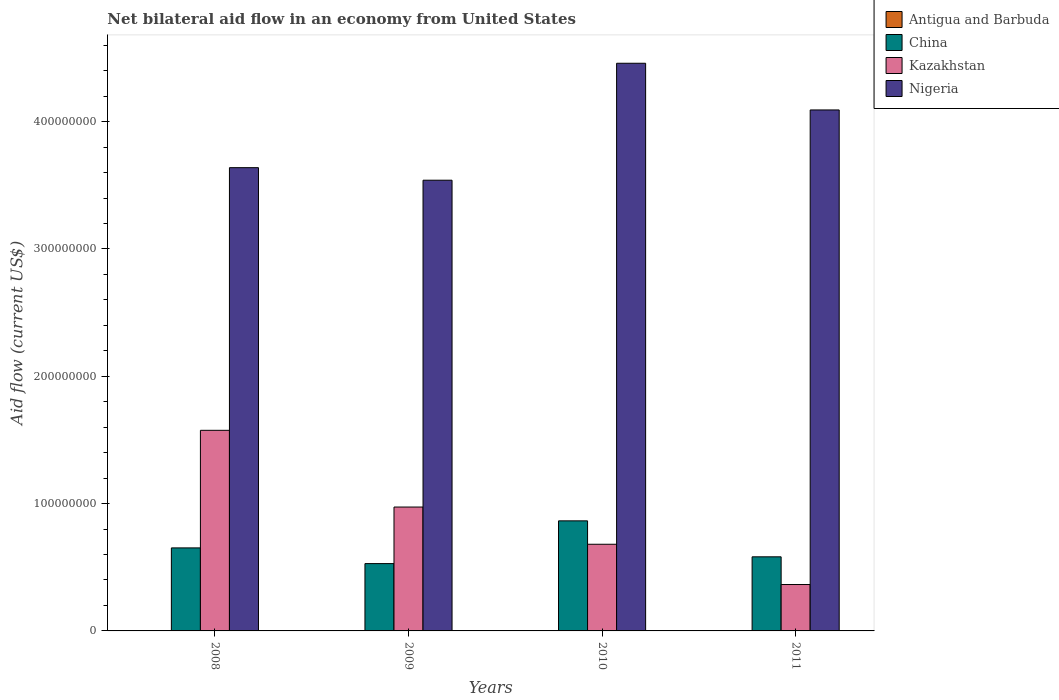How many different coloured bars are there?
Make the answer very short. 4. How many bars are there on the 2nd tick from the left?
Provide a short and direct response. 3. How many bars are there on the 1st tick from the right?
Give a very brief answer. 4. What is the net bilateral aid flow in Kazakhstan in 2008?
Offer a terse response. 1.58e+08. Across all years, what is the minimum net bilateral aid flow in Nigeria?
Keep it short and to the point. 3.54e+08. In which year was the net bilateral aid flow in China maximum?
Make the answer very short. 2010. What is the total net bilateral aid flow in China in the graph?
Your answer should be compact. 2.63e+08. What is the difference between the net bilateral aid flow in Kazakhstan in 2009 and that in 2010?
Make the answer very short. 2.92e+07. What is the difference between the net bilateral aid flow in Kazakhstan in 2008 and the net bilateral aid flow in Nigeria in 2010?
Provide a short and direct response. -2.88e+08. What is the average net bilateral aid flow in China per year?
Your response must be concise. 6.57e+07. In the year 2011, what is the difference between the net bilateral aid flow in Antigua and Barbuda and net bilateral aid flow in China?
Your answer should be very brief. -5.80e+07. In how many years, is the net bilateral aid flow in China greater than 360000000 US$?
Provide a short and direct response. 0. What is the ratio of the net bilateral aid flow in China in 2008 to that in 2010?
Ensure brevity in your answer.  0.75. What is the difference between the highest and the second highest net bilateral aid flow in Nigeria?
Provide a succinct answer. 3.67e+07. What is the difference between the highest and the lowest net bilateral aid flow in Kazakhstan?
Offer a very short reply. 1.21e+08. Is it the case that in every year, the sum of the net bilateral aid flow in Kazakhstan and net bilateral aid flow in Antigua and Barbuda is greater than the net bilateral aid flow in Nigeria?
Your response must be concise. No. Does the graph contain any zero values?
Your answer should be compact. Yes. How many legend labels are there?
Ensure brevity in your answer.  4. How are the legend labels stacked?
Make the answer very short. Vertical. What is the title of the graph?
Your response must be concise. Net bilateral aid flow in an economy from United States. Does "Mauritius" appear as one of the legend labels in the graph?
Your answer should be very brief. No. What is the label or title of the X-axis?
Provide a succinct answer. Years. What is the Aid flow (current US$) in China in 2008?
Your answer should be compact. 6.52e+07. What is the Aid flow (current US$) of Kazakhstan in 2008?
Provide a succinct answer. 1.58e+08. What is the Aid flow (current US$) of Nigeria in 2008?
Your answer should be compact. 3.64e+08. What is the Aid flow (current US$) in China in 2009?
Your response must be concise. 5.29e+07. What is the Aid flow (current US$) in Kazakhstan in 2009?
Keep it short and to the point. 9.73e+07. What is the Aid flow (current US$) of Nigeria in 2009?
Provide a short and direct response. 3.54e+08. What is the Aid flow (current US$) in China in 2010?
Your response must be concise. 8.65e+07. What is the Aid flow (current US$) in Kazakhstan in 2010?
Give a very brief answer. 6.81e+07. What is the Aid flow (current US$) in Nigeria in 2010?
Your response must be concise. 4.46e+08. What is the Aid flow (current US$) in China in 2011?
Offer a terse response. 5.82e+07. What is the Aid flow (current US$) in Kazakhstan in 2011?
Provide a short and direct response. 3.64e+07. What is the Aid flow (current US$) in Nigeria in 2011?
Make the answer very short. 4.09e+08. Across all years, what is the maximum Aid flow (current US$) in Antigua and Barbuda?
Make the answer very short. 1.80e+05. Across all years, what is the maximum Aid flow (current US$) of China?
Offer a very short reply. 8.65e+07. Across all years, what is the maximum Aid flow (current US$) of Kazakhstan?
Your answer should be very brief. 1.58e+08. Across all years, what is the maximum Aid flow (current US$) of Nigeria?
Provide a succinct answer. 4.46e+08. Across all years, what is the minimum Aid flow (current US$) of China?
Your answer should be very brief. 5.29e+07. Across all years, what is the minimum Aid flow (current US$) of Kazakhstan?
Give a very brief answer. 3.64e+07. Across all years, what is the minimum Aid flow (current US$) of Nigeria?
Keep it short and to the point. 3.54e+08. What is the total Aid flow (current US$) in Antigua and Barbuda in the graph?
Keep it short and to the point. 2.90e+05. What is the total Aid flow (current US$) of China in the graph?
Keep it short and to the point. 2.63e+08. What is the total Aid flow (current US$) in Kazakhstan in the graph?
Offer a very short reply. 3.59e+08. What is the total Aid flow (current US$) in Nigeria in the graph?
Keep it short and to the point. 1.57e+09. What is the difference between the Aid flow (current US$) in China in 2008 and that in 2009?
Offer a very short reply. 1.23e+07. What is the difference between the Aid flow (current US$) in Kazakhstan in 2008 and that in 2009?
Give a very brief answer. 6.03e+07. What is the difference between the Aid flow (current US$) in Nigeria in 2008 and that in 2009?
Ensure brevity in your answer.  9.86e+06. What is the difference between the Aid flow (current US$) of China in 2008 and that in 2010?
Offer a terse response. -2.12e+07. What is the difference between the Aid flow (current US$) of Kazakhstan in 2008 and that in 2010?
Give a very brief answer. 8.95e+07. What is the difference between the Aid flow (current US$) of Nigeria in 2008 and that in 2010?
Your response must be concise. -8.20e+07. What is the difference between the Aid flow (current US$) in China in 2008 and that in 2011?
Give a very brief answer. 7.01e+06. What is the difference between the Aid flow (current US$) in Kazakhstan in 2008 and that in 2011?
Your response must be concise. 1.21e+08. What is the difference between the Aid flow (current US$) of Nigeria in 2008 and that in 2011?
Offer a terse response. -4.53e+07. What is the difference between the Aid flow (current US$) in China in 2009 and that in 2010?
Offer a terse response. -3.36e+07. What is the difference between the Aid flow (current US$) of Kazakhstan in 2009 and that in 2010?
Make the answer very short. 2.92e+07. What is the difference between the Aid flow (current US$) in Nigeria in 2009 and that in 2010?
Give a very brief answer. -9.19e+07. What is the difference between the Aid flow (current US$) of China in 2009 and that in 2011?
Make the answer very short. -5.33e+06. What is the difference between the Aid flow (current US$) of Kazakhstan in 2009 and that in 2011?
Offer a terse response. 6.09e+07. What is the difference between the Aid flow (current US$) in Nigeria in 2009 and that in 2011?
Give a very brief answer. -5.52e+07. What is the difference between the Aid flow (current US$) in China in 2010 and that in 2011?
Provide a succinct answer. 2.82e+07. What is the difference between the Aid flow (current US$) in Kazakhstan in 2010 and that in 2011?
Your response must be concise. 3.16e+07. What is the difference between the Aid flow (current US$) in Nigeria in 2010 and that in 2011?
Keep it short and to the point. 3.67e+07. What is the difference between the Aid flow (current US$) of China in 2008 and the Aid flow (current US$) of Kazakhstan in 2009?
Provide a succinct answer. -3.21e+07. What is the difference between the Aid flow (current US$) in China in 2008 and the Aid flow (current US$) in Nigeria in 2009?
Provide a succinct answer. -2.89e+08. What is the difference between the Aid flow (current US$) of Kazakhstan in 2008 and the Aid flow (current US$) of Nigeria in 2009?
Keep it short and to the point. -1.96e+08. What is the difference between the Aid flow (current US$) in China in 2008 and the Aid flow (current US$) in Kazakhstan in 2010?
Give a very brief answer. -2.85e+06. What is the difference between the Aid flow (current US$) in China in 2008 and the Aid flow (current US$) in Nigeria in 2010?
Offer a terse response. -3.81e+08. What is the difference between the Aid flow (current US$) in Kazakhstan in 2008 and the Aid flow (current US$) in Nigeria in 2010?
Offer a terse response. -2.88e+08. What is the difference between the Aid flow (current US$) in China in 2008 and the Aid flow (current US$) in Kazakhstan in 2011?
Your response must be concise. 2.88e+07. What is the difference between the Aid flow (current US$) in China in 2008 and the Aid flow (current US$) in Nigeria in 2011?
Provide a succinct answer. -3.44e+08. What is the difference between the Aid flow (current US$) of Kazakhstan in 2008 and the Aid flow (current US$) of Nigeria in 2011?
Your answer should be compact. -2.52e+08. What is the difference between the Aid flow (current US$) in China in 2009 and the Aid flow (current US$) in Kazakhstan in 2010?
Ensure brevity in your answer.  -1.52e+07. What is the difference between the Aid flow (current US$) in China in 2009 and the Aid flow (current US$) in Nigeria in 2010?
Keep it short and to the point. -3.93e+08. What is the difference between the Aid flow (current US$) in Kazakhstan in 2009 and the Aid flow (current US$) in Nigeria in 2010?
Offer a terse response. -3.49e+08. What is the difference between the Aid flow (current US$) of China in 2009 and the Aid flow (current US$) of Kazakhstan in 2011?
Offer a very short reply. 1.64e+07. What is the difference between the Aid flow (current US$) in China in 2009 and the Aid flow (current US$) in Nigeria in 2011?
Make the answer very short. -3.56e+08. What is the difference between the Aid flow (current US$) of Kazakhstan in 2009 and the Aid flow (current US$) of Nigeria in 2011?
Offer a terse response. -3.12e+08. What is the difference between the Aid flow (current US$) of Antigua and Barbuda in 2010 and the Aid flow (current US$) of China in 2011?
Give a very brief answer. -5.81e+07. What is the difference between the Aid flow (current US$) of Antigua and Barbuda in 2010 and the Aid flow (current US$) of Kazakhstan in 2011?
Keep it short and to the point. -3.63e+07. What is the difference between the Aid flow (current US$) of Antigua and Barbuda in 2010 and the Aid flow (current US$) of Nigeria in 2011?
Provide a succinct answer. -4.09e+08. What is the difference between the Aid flow (current US$) of China in 2010 and the Aid flow (current US$) of Kazakhstan in 2011?
Provide a succinct answer. 5.00e+07. What is the difference between the Aid flow (current US$) in China in 2010 and the Aid flow (current US$) in Nigeria in 2011?
Provide a short and direct response. -3.23e+08. What is the difference between the Aid flow (current US$) in Kazakhstan in 2010 and the Aid flow (current US$) in Nigeria in 2011?
Provide a succinct answer. -3.41e+08. What is the average Aid flow (current US$) of Antigua and Barbuda per year?
Offer a terse response. 7.25e+04. What is the average Aid flow (current US$) in China per year?
Provide a short and direct response. 6.57e+07. What is the average Aid flow (current US$) in Kazakhstan per year?
Your answer should be very brief. 8.98e+07. What is the average Aid flow (current US$) in Nigeria per year?
Your response must be concise. 3.93e+08. In the year 2008, what is the difference between the Aid flow (current US$) of China and Aid flow (current US$) of Kazakhstan?
Offer a terse response. -9.24e+07. In the year 2008, what is the difference between the Aid flow (current US$) in China and Aid flow (current US$) in Nigeria?
Your answer should be very brief. -2.99e+08. In the year 2008, what is the difference between the Aid flow (current US$) in Kazakhstan and Aid flow (current US$) in Nigeria?
Your answer should be very brief. -2.06e+08. In the year 2009, what is the difference between the Aid flow (current US$) in China and Aid flow (current US$) in Kazakhstan?
Provide a succinct answer. -4.44e+07. In the year 2009, what is the difference between the Aid flow (current US$) in China and Aid flow (current US$) in Nigeria?
Offer a terse response. -3.01e+08. In the year 2009, what is the difference between the Aid flow (current US$) of Kazakhstan and Aid flow (current US$) of Nigeria?
Your answer should be compact. -2.57e+08. In the year 2010, what is the difference between the Aid flow (current US$) of Antigua and Barbuda and Aid flow (current US$) of China?
Offer a very short reply. -8.64e+07. In the year 2010, what is the difference between the Aid flow (current US$) in Antigua and Barbuda and Aid flow (current US$) in Kazakhstan?
Your response must be concise. -6.80e+07. In the year 2010, what is the difference between the Aid flow (current US$) in Antigua and Barbuda and Aid flow (current US$) in Nigeria?
Keep it short and to the point. -4.46e+08. In the year 2010, what is the difference between the Aid flow (current US$) of China and Aid flow (current US$) of Kazakhstan?
Offer a terse response. 1.84e+07. In the year 2010, what is the difference between the Aid flow (current US$) of China and Aid flow (current US$) of Nigeria?
Provide a succinct answer. -3.59e+08. In the year 2010, what is the difference between the Aid flow (current US$) of Kazakhstan and Aid flow (current US$) of Nigeria?
Make the answer very short. -3.78e+08. In the year 2011, what is the difference between the Aid flow (current US$) in Antigua and Barbuda and Aid flow (current US$) in China?
Your answer should be compact. -5.80e+07. In the year 2011, what is the difference between the Aid flow (current US$) of Antigua and Barbuda and Aid flow (current US$) of Kazakhstan?
Make the answer very short. -3.63e+07. In the year 2011, what is the difference between the Aid flow (current US$) in Antigua and Barbuda and Aid flow (current US$) in Nigeria?
Offer a terse response. -4.09e+08. In the year 2011, what is the difference between the Aid flow (current US$) of China and Aid flow (current US$) of Kazakhstan?
Keep it short and to the point. 2.18e+07. In the year 2011, what is the difference between the Aid flow (current US$) in China and Aid flow (current US$) in Nigeria?
Give a very brief answer. -3.51e+08. In the year 2011, what is the difference between the Aid flow (current US$) in Kazakhstan and Aid flow (current US$) in Nigeria?
Ensure brevity in your answer.  -3.73e+08. What is the ratio of the Aid flow (current US$) in China in 2008 to that in 2009?
Give a very brief answer. 1.23. What is the ratio of the Aid flow (current US$) in Kazakhstan in 2008 to that in 2009?
Provide a succinct answer. 1.62. What is the ratio of the Aid flow (current US$) in Nigeria in 2008 to that in 2009?
Provide a short and direct response. 1.03. What is the ratio of the Aid flow (current US$) of China in 2008 to that in 2010?
Provide a short and direct response. 0.75. What is the ratio of the Aid flow (current US$) of Kazakhstan in 2008 to that in 2010?
Your answer should be compact. 2.31. What is the ratio of the Aid flow (current US$) in Nigeria in 2008 to that in 2010?
Provide a succinct answer. 0.82. What is the ratio of the Aid flow (current US$) in China in 2008 to that in 2011?
Provide a succinct answer. 1.12. What is the ratio of the Aid flow (current US$) of Kazakhstan in 2008 to that in 2011?
Provide a short and direct response. 4.32. What is the ratio of the Aid flow (current US$) of Nigeria in 2008 to that in 2011?
Your response must be concise. 0.89. What is the ratio of the Aid flow (current US$) of China in 2009 to that in 2010?
Ensure brevity in your answer.  0.61. What is the ratio of the Aid flow (current US$) of Kazakhstan in 2009 to that in 2010?
Make the answer very short. 1.43. What is the ratio of the Aid flow (current US$) in Nigeria in 2009 to that in 2010?
Ensure brevity in your answer.  0.79. What is the ratio of the Aid flow (current US$) in China in 2009 to that in 2011?
Offer a very short reply. 0.91. What is the ratio of the Aid flow (current US$) in Kazakhstan in 2009 to that in 2011?
Your answer should be very brief. 2.67. What is the ratio of the Aid flow (current US$) of Nigeria in 2009 to that in 2011?
Provide a short and direct response. 0.87. What is the ratio of the Aid flow (current US$) of Antigua and Barbuda in 2010 to that in 2011?
Your answer should be very brief. 0.61. What is the ratio of the Aid flow (current US$) of China in 2010 to that in 2011?
Provide a short and direct response. 1.49. What is the ratio of the Aid flow (current US$) in Kazakhstan in 2010 to that in 2011?
Keep it short and to the point. 1.87. What is the ratio of the Aid flow (current US$) in Nigeria in 2010 to that in 2011?
Make the answer very short. 1.09. What is the difference between the highest and the second highest Aid flow (current US$) in China?
Keep it short and to the point. 2.12e+07. What is the difference between the highest and the second highest Aid flow (current US$) in Kazakhstan?
Your answer should be compact. 6.03e+07. What is the difference between the highest and the second highest Aid flow (current US$) in Nigeria?
Offer a very short reply. 3.67e+07. What is the difference between the highest and the lowest Aid flow (current US$) of Antigua and Barbuda?
Offer a terse response. 1.80e+05. What is the difference between the highest and the lowest Aid flow (current US$) of China?
Offer a terse response. 3.36e+07. What is the difference between the highest and the lowest Aid flow (current US$) in Kazakhstan?
Offer a very short reply. 1.21e+08. What is the difference between the highest and the lowest Aid flow (current US$) in Nigeria?
Ensure brevity in your answer.  9.19e+07. 